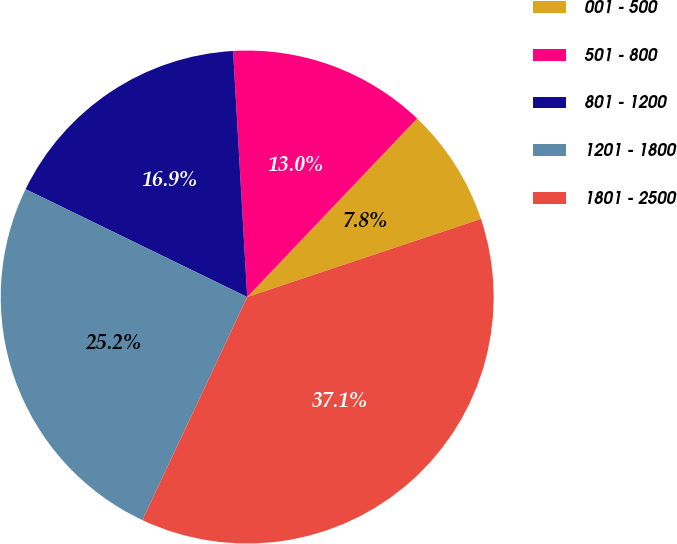Convert chart. <chart><loc_0><loc_0><loc_500><loc_500><pie_chart><fcel>001 - 500<fcel>501 - 800<fcel>801 - 1200<fcel>1201 - 1800<fcel>1801 - 2500<nl><fcel>7.76%<fcel>13.02%<fcel>16.88%<fcel>25.22%<fcel>37.13%<nl></chart> 